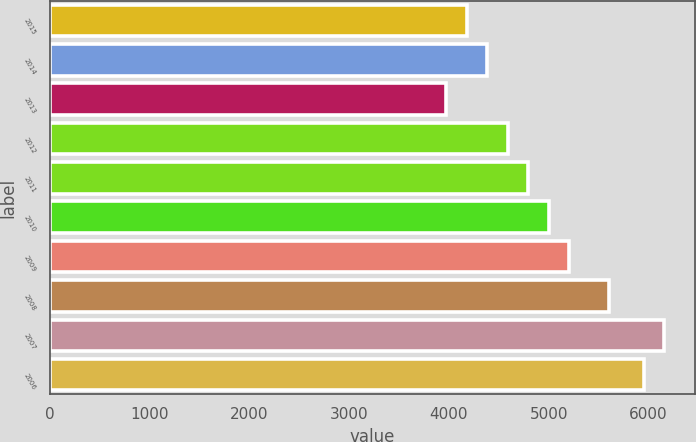Convert chart to OTSL. <chart><loc_0><loc_0><loc_500><loc_500><bar_chart><fcel>2015<fcel>2014<fcel>2013<fcel>2012<fcel>2011<fcel>2010<fcel>2009<fcel>2008<fcel>2007<fcel>2006<nl><fcel>4178.4<fcel>4383.8<fcel>3973<fcel>4589.2<fcel>4794.6<fcel>5000<fcel>5205.4<fcel>5608<fcel>6160.4<fcel>5955<nl></chart> 